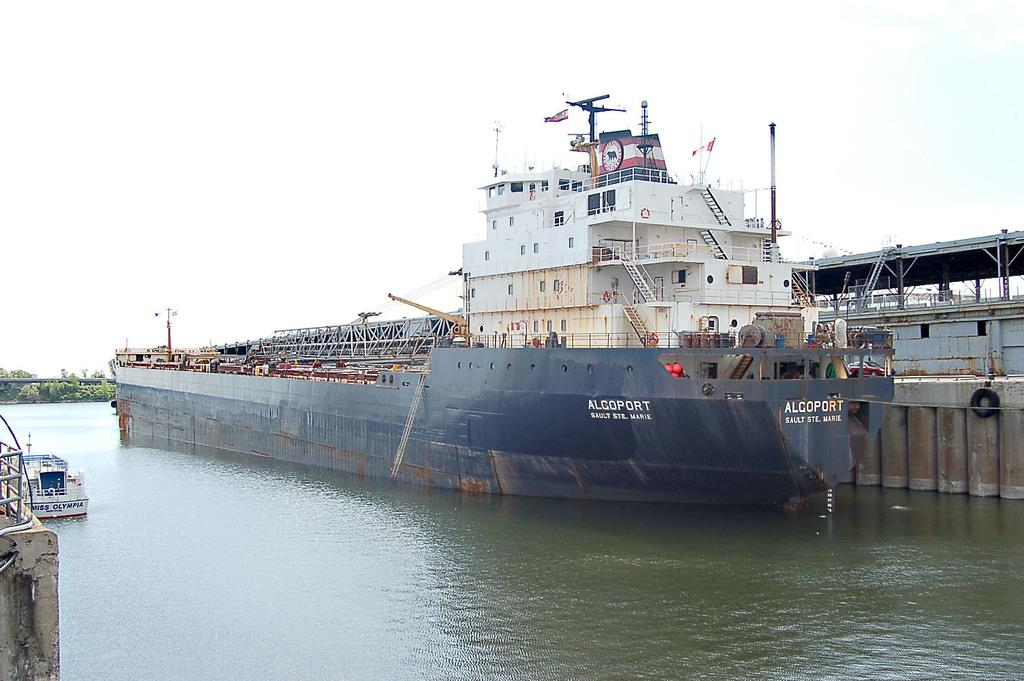What is on the water in the image? There are ships on the water in the image. What type of vegetation is present in the image? There are trees in the image. What structures can be seen in the image? There is a pole, a fence, and a wall in the image. What is visible at the top of the image? The sky is visible at the top of the image. Can you tell me how many dogs are present in the image? There are no dogs present in the image. What type of bird can be seen flying in the image? There are no birds visible in the image. 